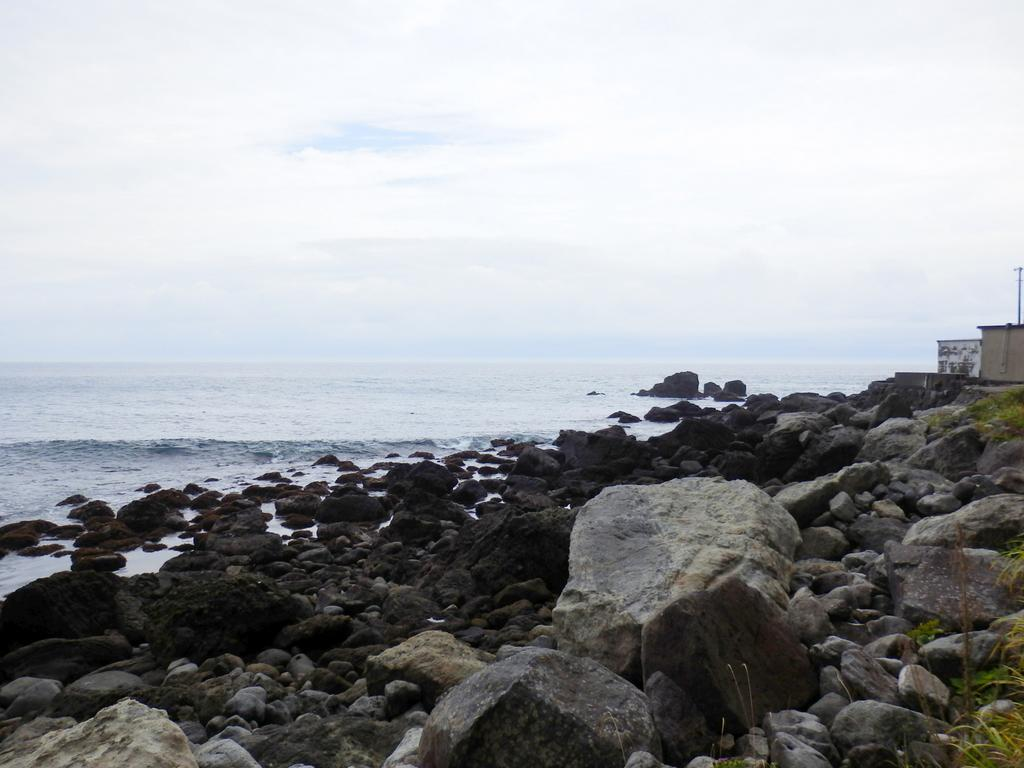What type of natural elements can be seen in the image? There are stones and rocks in the image. What else is present in the image besides stones and rocks? There is water visible in the image. What can be seen in the sky in the image? There are clouds in the sky in the image. What color is the paint used to decorate the zinc in the image? There is no paint or zinc present in the image; it features stones, rocks, water, and clouds. 